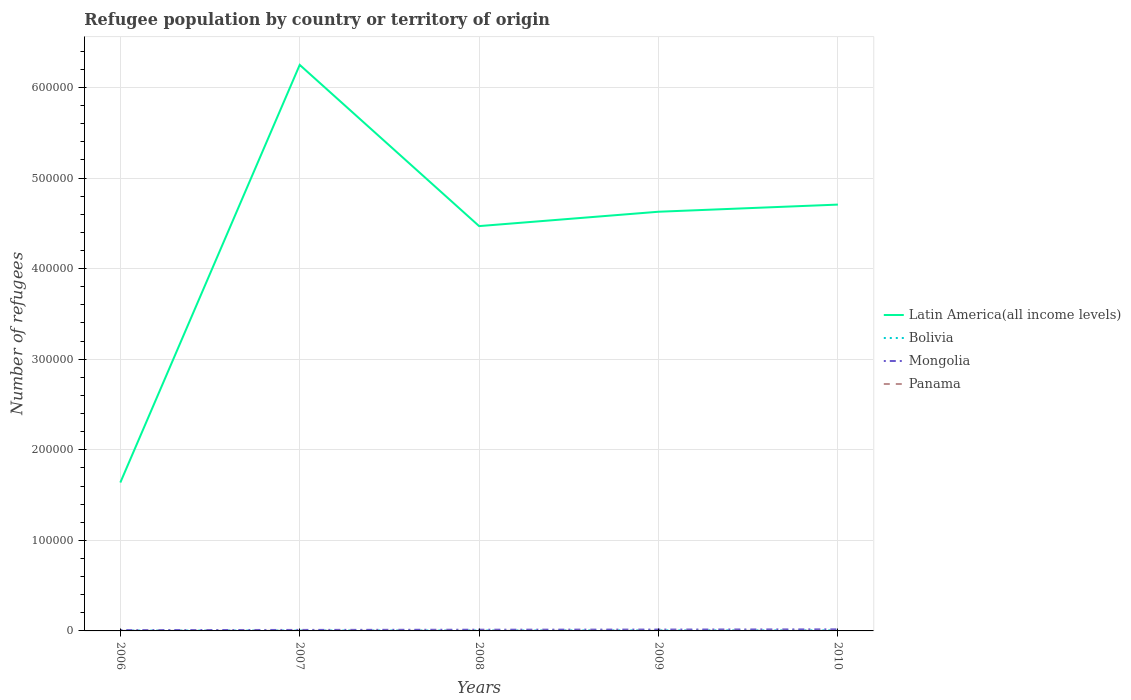Does the line corresponding to Mongolia intersect with the line corresponding to Panama?
Your answer should be very brief. No. Across all years, what is the maximum number of refugees in Mongolia?
Your answer should be compact. 868. In which year was the number of refugees in Latin America(all income levels) maximum?
Provide a succinct answer. 2006. What is the total number of refugees in Panama in the graph?
Provide a succinct answer. -25. What is the difference between the highest and the second highest number of refugees in Panama?
Offer a very short reply. 36. What is the difference between the highest and the lowest number of refugees in Latin America(all income levels)?
Offer a very short reply. 4. How many lines are there?
Your response must be concise. 4. How many years are there in the graph?
Your response must be concise. 5. What is the difference between two consecutive major ticks on the Y-axis?
Give a very brief answer. 1.00e+05. Does the graph contain any zero values?
Your answer should be compact. No. Does the graph contain grids?
Offer a terse response. Yes. Where does the legend appear in the graph?
Ensure brevity in your answer.  Center right. How are the legend labels stacked?
Your answer should be compact. Vertical. What is the title of the graph?
Give a very brief answer. Refugee population by country or territory of origin. Does "Nicaragua" appear as one of the legend labels in the graph?
Provide a succinct answer. No. What is the label or title of the Y-axis?
Keep it short and to the point. Number of refugees. What is the Number of refugees of Latin America(all income levels) in 2006?
Keep it short and to the point. 1.64e+05. What is the Number of refugees in Bolivia in 2006?
Make the answer very short. 374. What is the Number of refugees of Mongolia in 2006?
Your response must be concise. 868. What is the Number of refugees in Latin America(all income levels) in 2007?
Make the answer very short. 6.25e+05. What is the Number of refugees of Bolivia in 2007?
Your response must be concise. 428. What is the Number of refugees of Mongolia in 2007?
Provide a succinct answer. 1101. What is the Number of refugees of Panama in 2007?
Keep it short and to the point. 109. What is the Number of refugees of Latin America(all income levels) in 2008?
Ensure brevity in your answer.  4.47e+05. What is the Number of refugees in Bolivia in 2008?
Make the answer very short. 454. What is the Number of refugees of Mongolia in 2008?
Your response must be concise. 1333. What is the Number of refugees in Panama in 2008?
Offer a terse response. 111. What is the Number of refugees of Latin America(all income levels) in 2009?
Provide a succinct answer. 4.63e+05. What is the Number of refugees in Bolivia in 2009?
Your answer should be compact. 573. What is the Number of refugees of Mongolia in 2009?
Your answer should be very brief. 1495. What is the Number of refugees in Panama in 2009?
Keep it short and to the point. 105. What is the Number of refugees of Latin America(all income levels) in 2010?
Provide a succinct answer. 4.71e+05. What is the Number of refugees in Bolivia in 2010?
Keep it short and to the point. 590. What is the Number of refugees of Mongolia in 2010?
Make the answer very short. 1724. What is the Number of refugees of Panama in 2010?
Ensure brevity in your answer.  100. Across all years, what is the maximum Number of refugees of Latin America(all income levels)?
Provide a succinct answer. 6.25e+05. Across all years, what is the maximum Number of refugees in Bolivia?
Keep it short and to the point. 590. Across all years, what is the maximum Number of refugees in Mongolia?
Your answer should be compact. 1724. Across all years, what is the maximum Number of refugees in Panama?
Offer a terse response. 111. Across all years, what is the minimum Number of refugees in Latin America(all income levels)?
Keep it short and to the point. 1.64e+05. Across all years, what is the minimum Number of refugees of Bolivia?
Provide a succinct answer. 374. Across all years, what is the minimum Number of refugees of Mongolia?
Keep it short and to the point. 868. What is the total Number of refugees in Latin America(all income levels) in the graph?
Make the answer very short. 2.17e+06. What is the total Number of refugees of Bolivia in the graph?
Your answer should be compact. 2419. What is the total Number of refugees of Mongolia in the graph?
Make the answer very short. 6521. What is the total Number of refugees of Panama in the graph?
Make the answer very short. 500. What is the difference between the Number of refugees in Latin America(all income levels) in 2006 and that in 2007?
Offer a very short reply. -4.61e+05. What is the difference between the Number of refugees in Bolivia in 2006 and that in 2007?
Your answer should be very brief. -54. What is the difference between the Number of refugees of Mongolia in 2006 and that in 2007?
Offer a terse response. -233. What is the difference between the Number of refugees of Panama in 2006 and that in 2007?
Ensure brevity in your answer.  -34. What is the difference between the Number of refugees in Latin America(all income levels) in 2006 and that in 2008?
Your response must be concise. -2.83e+05. What is the difference between the Number of refugees in Bolivia in 2006 and that in 2008?
Provide a short and direct response. -80. What is the difference between the Number of refugees of Mongolia in 2006 and that in 2008?
Offer a terse response. -465. What is the difference between the Number of refugees of Panama in 2006 and that in 2008?
Your response must be concise. -36. What is the difference between the Number of refugees in Latin America(all income levels) in 2006 and that in 2009?
Your answer should be compact. -2.99e+05. What is the difference between the Number of refugees in Bolivia in 2006 and that in 2009?
Your answer should be compact. -199. What is the difference between the Number of refugees in Mongolia in 2006 and that in 2009?
Make the answer very short. -627. What is the difference between the Number of refugees in Latin America(all income levels) in 2006 and that in 2010?
Ensure brevity in your answer.  -3.07e+05. What is the difference between the Number of refugees in Bolivia in 2006 and that in 2010?
Your answer should be compact. -216. What is the difference between the Number of refugees in Mongolia in 2006 and that in 2010?
Provide a short and direct response. -856. What is the difference between the Number of refugees in Panama in 2006 and that in 2010?
Your answer should be compact. -25. What is the difference between the Number of refugees of Latin America(all income levels) in 2007 and that in 2008?
Your answer should be compact. 1.78e+05. What is the difference between the Number of refugees of Mongolia in 2007 and that in 2008?
Make the answer very short. -232. What is the difference between the Number of refugees in Latin America(all income levels) in 2007 and that in 2009?
Ensure brevity in your answer.  1.62e+05. What is the difference between the Number of refugees in Bolivia in 2007 and that in 2009?
Give a very brief answer. -145. What is the difference between the Number of refugees of Mongolia in 2007 and that in 2009?
Provide a short and direct response. -394. What is the difference between the Number of refugees of Panama in 2007 and that in 2009?
Keep it short and to the point. 4. What is the difference between the Number of refugees in Latin America(all income levels) in 2007 and that in 2010?
Your response must be concise. 1.54e+05. What is the difference between the Number of refugees in Bolivia in 2007 and that in 2010?
Offer a very short reply. -162. What is the difference between the Number of refugees in Mongolia in 2007 and that in 2010?
Provide a succinct answer. -623. What is the difference between the Number of refugees of Panama in 2007 and that in 2010?
Provide a short and direct response. 9. What is the difference between the Number of refugees in Latin America(all income levels) in 2008 and that in 2009?
Your answer should be compact. -1.59e+04. What is the difference between the Number of refugees of Bolivia in 2008 and that in 2009?
Offer a terse response. -119. What is the difference between the Number of refugees in Mongolia in 2008 and that in 2009?
Offer a very short reply. -162. What is the difference between the Number of refugees in Latin America(all income levels) in 2008 and that in 2010?
Provide a succinct answer. -2.37e+04. What is the difference between the Number of refugees of Bolivia in 2008 and that in 2010?
Make the answer very short. -136. What is the difference between the Number of refugees in Mongolia in 2008 and that in 2010?
Your answer should be very brief. -391. What is the difference between the Number of refugees in Panama in 2008 and that in 2010?
Your answer should be very brief. 11. What is the difference between the Number of refugees in Latin America(all income levels) in 2009 and that in 2010?
Offer a very short reply. -7883. What is the difference between the Number of refugees of Mongolia in 2009 and that in 2010?
Provide a succinct answer. -229. What is the difference between the Number of refugees in Latin America(all income levels) in 2006 and the Number of refugees in Bolivia in 2007?
Give a very brief answer. 1.63e+05. What is the difference between the Number of refugees of Latin America(all income levels) in 2006 and the Number of refugees of Mongolia in 2007?
Make the answer very short. 1.63e+05. What is the difference between the Number of refugees of Latin America(all income levels) in 2006 and the Number of refugees of Panama in 2007?
Your response must be concise. 1.64e+05. What is the difference between the Number of refugees in Bolivia in 2006 and the Number of refugees in Mongolia in 2007?
Give a very brief answer. -727. What is the difference between the Number of refugees of Bolivia in 2006 and the Number of refugees of Panama in 2007?
Give a very brief answer. 265. What is the difference between the Number of refugees in Mongolia in 2006 and the Number of refugees in Panama in 2007?
Your answer should be compact. 759. What is the difference between the Number of refugees of Latin America(all income levels) in 2006 and the Number of refugees of Bolivia in 2008?
Provide a short and direct response. 1.63e+05. What is the difference between the Number of refugees of Latin America(all income levels) in 2006 and the Number of refugees of Mongolia in 2008?
Ensure brevity in your answer.  1.62e+05. What is the difference between the Number of refugees in Latin America(all income levels) in 2006 and the Number of refugees in Panama in 2008?
Keep it short and to the point. 1.64e+05. What is the difference between the Number of refugees in Bolivia in 2006 and the Number of refugees in Mongolia in 2008?
Offer a very short reply. -959. What is the difference between the Number of refugees in Bolivia in 2006 and the Number of refugees in Panama in 2008?
Give a very brief answer. 263. What is the difference between the Number of refugees in Mongolia in 2006 and the Number of refugees in Panama in 2008?
Your response must be concise. 757. What is the difference between the Number of refugees in Latin America(all income levels) in 2006 and the Number of refugees in Bolivia in 2009?
Give a very brief answer. 1.63e+05. What is the difference between the Number of refugees in Latin America(all income levels) in 2006 and the Number of refugees in Mongolia in 2009?
Your response must be concise. 1.62e+05. What is the difference between the Number of refugees in Latin America(all income levels) in 2006 and the Number of refugees in Panama in 2009?
Provide a succinct answer. 1.64e+05. What is the difference between the Number of refugees of Bolivia in 2006 and the Number of refugees of Mongolia in 2009?
Make the answer very short. -1121. What is the difference between the Number of refugees of Bolivia in 2006 and the Number of refugees of Panama in 2009?
Offer a terse response. 269. What is the difference between the Number of refugees in Mongolia in 2006 and the Number of refugees in Panama in 2009?
Ensure brevity in your answer.  763. What is the difference between the Number of refugees in Latin America(all income levels) in 2006 and the Number of refugees in Bolivia in 2010?
Offer a terse response. 1.63e+05. What is the difference between the Number of refugees in Latin America(all income levels) in 2006 and the Number of refugees in Mongolia in 2010?
Your response must be concise. 1.62e+05. What is the difference between the Number of refugees in Latin America(all income levels) in 2006 and the Number of refugees in Panama in 2010?
Provide a succinct answer. 1.64e+05. What is the difference between the Number of refugees of Bolivia in 2006 and the Number of refugees of Mongolia in 2010?
Your response must be concise. -1350. What is the difference between the Number of refugees in Bolivia in 2006 and the Number of refugees in Panama in 2010?
Offer a terse response. 274. What is the difference between the Number of refugees in Mongolia in 2006 and the Number of refugees in Panama in 2010?
Ensure brevity in your answer.  768. What is the difference between the Number of refugees in Latin America(all income levels) in 2007 and the Number of refugees in Bolivia in 2008?
Offer a terse response. 6.24e+05. What is the difference between the Number of refugees in Latin America(all income levels) in 2007 and the Number of refugees in Mongolia in 2008?
Provide a succinct answer. 6.24e+05. What is the difference between the Number of refugees in Latin America(all income levels) in 2007 and the Number of refugees in Panama in 2008?
Offer a very short reply. 6.25e+05. What is the difference between the Number of refugees of Bolivia in 2007 and the Number of refugees of Mongolia in 2008?
Ensure brevity in your answer.  -905. What is the difference between the Number of refugees in Bolivia in 2007 and the Number of refugees in Panama in 2008?
Keep it short and to the point. 317. What is the difference between the Number of refugees in Mongolia in 2007 and the Number of refugees in Panama in 2008?
Provide a succinct answer. 990. What is the difference between the Number of refugees in Latin America(all income levels) in 2007 and the Number of refugees in Bolivia in 2009?
Ensure brevity in your answer.  6.24e+05. What is the difference between the Number of refugees of Latin America(all income levels) in 2007 and the Number of refugees of Mongolia in 2009?
Provide a succinct answer. 6.23e+05. What is the difference between the Number of refugees in Latin America(all income levels) in 2007 and the Number of refugees in Panama in 2009?
Provide a succinct answer. 6.25e+05. What is the difference between the Number of refugees of Bolivia in 2007 and the Number of refugees of Mongolia in 2009?
Give a very brief answer. -1067. What is the difference between the Number of refugees of Bolivia in 2007 and the Number of refugees of Panama in 2009?
Your answer should be very brief. 323. What is the difference between the Number of refugees of Mongolia in 2007 and the Number of refugees of Panama in 2009?
Provide a succinct answer. 996. What is the difference between the Number of refugees in Latin America(all income levels) in 2007 and the Number of refugees in Bolivia in 2010?
Your answer should be compact. 6.24e+05. What is the difference between the Number of refugees of Latin America(all income levels) in 2007 and the Number of refugees of Mongolia in 2010?
Your answer should be compact. 6.23e+05. What is the difference between the Number of refugees in Latin America(all income levels) in 2007 and the Number of refugees in Panama in 2010?
Offer a terse response. 6.25e+05. What is the difference between the Number of refugees of Bolivia in 2007 and the Number of refugees of Mongolia in 2010?
Offer a very short reply. -1296. What is the difference between the Number of refugees in Bolivia in 2007 and the Number of refugees in Panama in 2010?
Your response must be concise. 328. What is the difference between the Number of refugees in Mongolia in 2007 and the Number of refugees in Panama in 2010?
Provide a short and direct response. 1001. What is the difference between the Number of refugees of Latin America(all income levels) in 2008 and the Number of refugees of Bolivia in 2009?
Offer a very short reply. 4.46e+05. What is the difference between the Number of refugees of Latin America(all income levels) in 2008 and the Number of refugees of Mongolia in 2009?
Ensure brevity in your answer.  4.45e+05. What is the difference between the Number of refugees in Latin America(all income levels) in 2008 and the Number of refugees in Panama in 2009?
Make the answer very short. 4.47e+05. What is the difference between the Number of refugees of Bolivia in 2008 and the Number of refugees of Mongolia in 2009?
Your answer should be very brief. -1041. What is the difference between the Number of refugees of Bolivia in 2008 and the Number of refugees of Panama in 2009?
Offer a terse response. 349. What is the difference between the Number of refugees in Mongolia in 2008 and the Number of refugees in Panama in 2009?
Ensure brevity in your answer.  1228. What is the difference between the Number of refugees of Latin America(all income levels) in 2008 and the Number of refugees of Bolivia in 2010?
Your answer should be very brief. 4.46e+05. What is the difference between the Number of refugees of Latin America(all income levels) in 2008 and the Number of refugees of Mongolia in 2010?
Your answer should be compact. 4.45e+05. What is the difference between the Number of refugees in Latin America(all income levels) in 2008 and the Number of refugees in Panama in 2010?
Offer a very short reply. 4.47e+05. What is the difference between the Number of refugees of Bolivia in 2008 and the Number of refugees of Mongolia in 2010?
Keep it short and to the point. -1270. What is the difference between the Number of refugees of Bolivia in 2008 and the Number of refugees of Panama in 2010?
Offer a very short reply. 354. What is the difference between the Number of refugees of Mongolia in 2008 and the Number of refugees of Panama in 2010?
Ensure brevity in your answer.  1233. What is the difference between the Number of refugees of Latin America(all income levels) in 2009 and the Number of refugees of Bolivia in 2010?
Keep it short and to the point. 4.62e+05. What is the difference between the Number of refugees in Latin America(all income levels) in 2009 and the Number of refugees in Mongolia in 2010?
Keep it short and to the point. 4.61e+05. What is the difference between the Number of refugees of Latin America(all income levels) in 2009 and the Number of refugees of Panama in 2010?
Ensure brevity in your answer.  4.63e+05. What is the difference between the Number of refugees in Bolivia in 2009 and the Number of refugees in Mongolia in 2010?
Give a very brief answer. -1151. What is the difference between the Number of refugees of Bolivia in 2009 and the Number of refugees of Panama in 2010?
Provide a succinct answer. 473. What is the difference between the Number of refugees of Mongolia in 2009 and the Number of refugees of Panama in 2010?
Make the answer very short. 1395. What is the average Number of refugees of Latin America(all income levels) per year?
Ensure brevity in your answer.  4.34e+05. What is the average Number of refugees in Bolivia per year?
Your response must be concise. 483.8. What is the average Number of refugees in Mongolia per year?
Offer a terse response. 1304.2. What is the average Number of refugees of Panama per year?
Provide a succinct answer. 100. In the year 2006, what is the difference between the Number of refugees of Latin America(all income levels) and Number of refugees of Bolivia?
Offer a terse response. 1.63e+05. In the year 2006, what is the difference between the Number of refugees of Latin America(all income levels) and Number of refugees of Mongolia?
Offer a very short reply. 1.63e+05. In the year 2006, what is the difference between the Number of refugees of Latin America(all income levels) and Number of refugees of Panama?
Ensure brevity in your answer.  1.64e+05. In the year 2006, what is the difference between the Number of refugees of Bolivia and Number of refugees of Mongolia?
Your response must be concise. -494. In the year 2006, what is the difference between the Number of refugees of Bolivia and Number of refugees of Panama?
Ensure brevity in your answer.  299. In the year 2006, what is the difference between the Number of refugees of Mongolia and Number of refugees of Panama?
Offer a terse response. 793. In the year 2007, what is the difference between the Number of refugees of Latin America(all income levels) and Number of refugees of Bolivia?
Keep it short and to the point. 6.25e+05. In the year 2007, what is the difference between the Number of refugees in Latin America(all income levels) and Number of refugees in Mongolia?
Provide a short and direct response. 6.24e+05. In the year 2007, what is the difference between the Number of refugees of Latin America(all income levels) and Number of refugees of Panama?
Offer a terse response. 6.25e+05. In the year 2007, what is the difference between the Number of refugees in Bolivia and Number of refugees in Mongolia?
Give a very brief answer. -673. In the year 2007, what is the difference between the Number of refugees in Bolivia and Number of refugees in Panama?
Make the answer very short. 319. In the year 2007, what is the difference between the Number of refugees in Mongolia and Number of refugees in Panama?
Offer a terse response. 992. In the year 2008, what is the difference between the Number of refugees of Latin America(all income levels) and Number of refugees of Bolivia?
Your answer should be compact. 4.46e+05. In the year 2008, what is the difference between the Number of refugees in Latin America(all income levels) and Number of refugees in Mongolia?
Provide a succinct answer. 4.46e+05. In the year 2008, what is the difference between the Number of refugees of Latin America(all income levels) and Number of refugees of Panama?
Provide a short and direct response. 4.47e+05. In the year 2008, what is the difference between the Number of refugees in Bolivia and Number of refugees in Mongolia?
Keep it short and to the point. -879. In the year 2008, what is the difference between the Number of refugees of Bolivia and Number of refugees of Panama?
Make the answer very short. 343. In the year 2008, what is the difference between the Number of refugees of Mongolia and Number of refugees of Panama?
Keep it short and to the point. 1222. In the year 2009, what is the difference between the Number of refugees in Latin America(all income levels) and Number of refugees in Bolivia?
Provide a short and direct response. 4.62e+05. In the year 2009, what is the difference between the Number of refugees of Latin America(all income levels) and Number of refugees of Mongolia?
Your answer should be very brief. 4.61e+05. In the year 2009, what is the difference between the Number of refugees in Latin America(all income levels) and Number of refugees in Panama?
Your answer should be compact. 4.63e+05. In the year 2009, what is the difference between the Number of refugees in Bolivia and Number of refugees in Mongolia?
Ensure brevity in your answer.  -922. In the year 2009, what is the difference between the Number of refugees in Bolivia and Number of refugees in Panama?
Provide a short and direct response. 468. In the year 2009, what is the difference between the Number of refugees in Mongolia and Number of refugees in Panama?
Your answer should be very brief. 1390. In the year 2010, what is the difference between the Number of refugees in Latin America(all income levels) and Number of refugees in Bolivia?
Keep it short and to the point. 4.70e+05. In the year 2010, what is the difference between the Number of refugees in Latin America(all income levels) and Number of refugees in Mongolia?
Give a very brief answer. 4.69e+05. In the year 2010, what is the difference between the Number of refugees of Latin America(all income levels) and Number of refugees of Panama?
Keep it short and to the point. 4.71e+05. In the year 2010, what is the difference between the Number of refugees in Bolivia and Number of refugees in Mongolia?
Provide a short and direct response. -1134. In the year 2010, what is the difference between the Number of refugees of Bolivia and Number of refugees of Panama?
Ensure brevity in your answer.  490. In the year 2010, what is the difference between the Number of refugees of Mongolia and Number of refugees of Panama?
Ensure brevity in your answer.  1624. What is the ratio of the Number of refugees of Latin America(all income levels) in 2006 to that in 2007?
Your response must be concise. 0.26. What is the ratio of the Number of refugees in Bolivia in 2006 to that in 2007?
Offer a terse response. 0.87. What is the ratio of the Number of refugees of Mongolia in 2006 to that in 2007?
Make the answer very short. 0.79. What is the ratio of the Number of refugees of Panama in 2006 to that in 2007?
Your response must be concise. 0.69. What is the ratio of the Number of refugees in Latin America(all income levels) in 2006 to that in 2008?
Give a very brief answer. 0.37. What is the ratio of the Number of refugees of Bolivia in 2006 to that in 2008?
Provide a short and direct response. 0.82. What is the ratio of the Number of refugees in Mongolia in 2006 to that in 2008?
Offer a terse response. 0.65. What is the ratio of the Number of refugees of Panama in 2006 to that in 2008?
Offer a terse response. 0.68. What is the ratio of the Number of refugees of Latin America(all income levels) in 2006 to that in 2009?
Offer a terse response. 0.35. What is the ratio of the Number of refugees in Bolivia in 2006 to that in 2009?
Offer a terse response. 0.65. What is the ratio of the Number of refugees of Mongolia in 2006 to that in 2009?
Your answer should be very brief. 0.58. What is the ratio of the Number of refugees of Latin America(all income levels) in 2006 to that in 2010?
Keep it short and to the point. 0.35. What is the ratio of the Number of refugees in Bolivia in 2006 to that in 2010?
Your response must be concise. 0.63. What is the ratio of the Number of refugees of Mongolia in 2006 to that in 2010?
Give a very brief answer. 0.5. What is the ratio of the Number of refugees in Latin America(all income levels) in 2007 to that in 2008?
Your answer should be very brief. 1.4. What is the ratio of the Number of refugees in Bolivia in 2007 to that in 2008?
Ensure brevity in your answer.  0.94. What is the ratio of the Number of refugees of Mongolia in 2007 to that in 2008?
Your response must be concise. 0.83. What is the ratio of the Number of refugees of Latin America(all income levels) in 2007 to that in 2009?
Offer a very short reply. 1.35. What is the ratio of the Number of refugees in Bolivia in 2007 to that in 2009?
Provide a succinct answer. 0.75. What is the ratio of the Number of refugees of Mongolia in 2007 to that in 2009?
Make the answer very short. 0.74. What is the ratio of the Number of refugees in Panama in 2007 to that in 2009?
Your answer should be very brief. 1.04. What is the ratio of the Number of refugees of Latin America(all income levels) in 2007 to that in 2010?
Offer a very short reply. 1.33. What is the ratio of the Number of refugees of Bolivia in 2007 to that in 2010?
Give a very brief answer. 0.73. What is the ratio of the Number of refugees in Mongolia in 2007 to that in 2010?
Offer a very short reply. 0.64. What is the ratio of the Number of refugees in Panama in 2007 to that in 2010?
Your answer should be very brief. 1.09. What is the ratio of the Number of refugees in Latin America(all income levels) in 2008 to that in 2009?
Offer a terse response. 0.97. What is the ratio of the Number of refugees in Bolivia in 2008 to that in 2009?
Give a very brief answer. 0.79. What is the ratio of the Number of refugees of Mongolia in 2008 to that in 2009?
Offer a terse response. 0.89. What is the ratio of the Number of refugees of Panama in 2008 to that in 2009?
Offer a terse response. 1.06. What is the ratio of the Number of refugees in Latin America(all income levels) in 2008 to that in 2010?
Provide a succinct answer. 0.95. What is the ratio of the Number of refugees in Bolivia in 2008 to that in 2010?
Make the answer very short. 0.77. What is the ratio of the Number of refugees in Mongolia in 2008 to that in 2010?
Your response must be concise. 0.77. What is the ratio of the Number of refugees of Panama in 2008 to that in 2010?
Give a very brief answer. 1.11. What is the ratio of the Number of refugees of Latin America(all income levels) in 2009 to that in 2010?
Your answer should be very brief. 0.98. What is the ratio of the Number of refugees in Bolivia in 2009 to that in 2010?
Offer a terse response. 0.97. What is the ratio of the Number of refugees in Mongolia in 2009 to that in 2010?
Ensure brevity in your answer.  0.87. What is the difference between the highest and the second highest Number of refugees of Latin America(all income levels)?
Your answer should be very brief. 1.54e+05. What is the difference between the highest and the second highest Number of refugees in Bolivia?
Make the answer very short. 17. What is the difference between the highest and the second highest Number of refugees in Mongolia?
Your response must be concise. 229. What is the difference between the highest and the second highest Number of refugees of Panama?
Your answer should be very brief. 2. What is the difference between the highest and the lowest Number of refugees of Latin America(all income levels)?
Your response must be concise. 4.61e+05. What is the difference between the highest and the lowest Number of refugees in Bolivia?
Keep it short and to the point. 216. What is the difference between the highest and the lowest Number of refugees in Mongolia?
Keep it short and to the point. 856. 